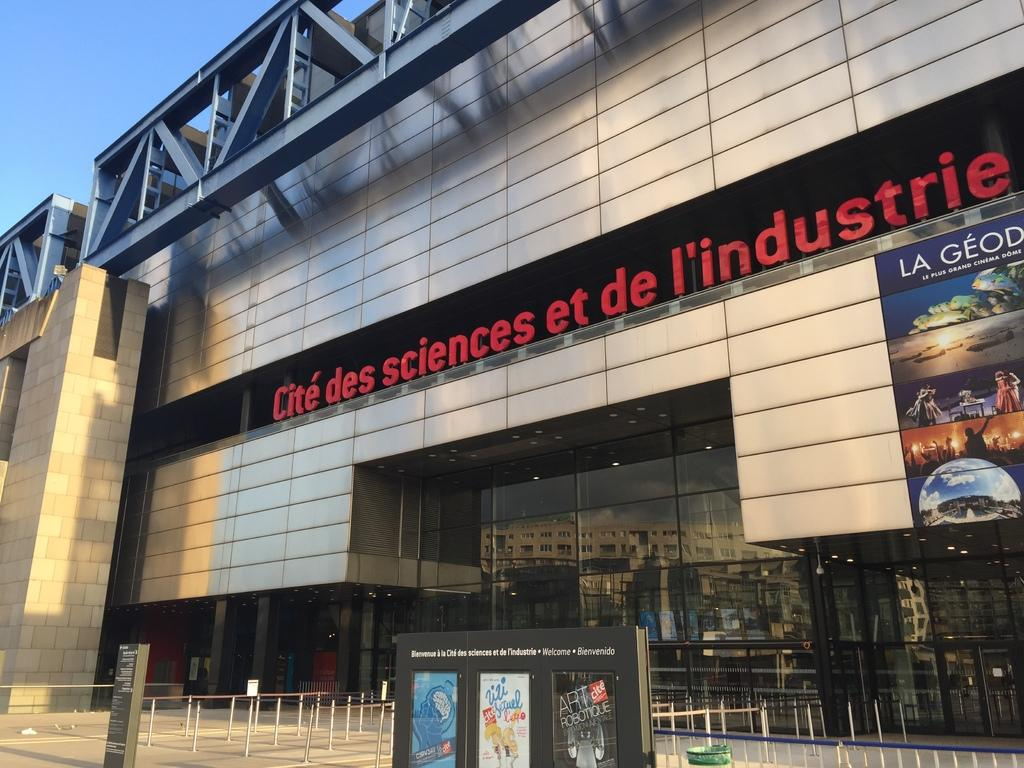<image>
Relay a brief, clear account of the picture shown. The building is the Cite de sciences l'industrie. 